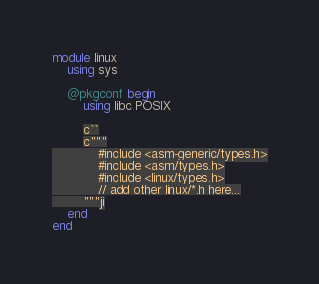<code> <loc_0><loc_0><loc_500><loc_500><_Julia_>module linux
	using sys
	
	@pkgconf begin
		using libc.POSIX
		
		c``
		c"""
			#include <asm-generic/types.h>
			#include <asm/types.h>
			#include <linux/types.h>
			// add other linux/*.h here...
		"""ji
	end
end
</code> 